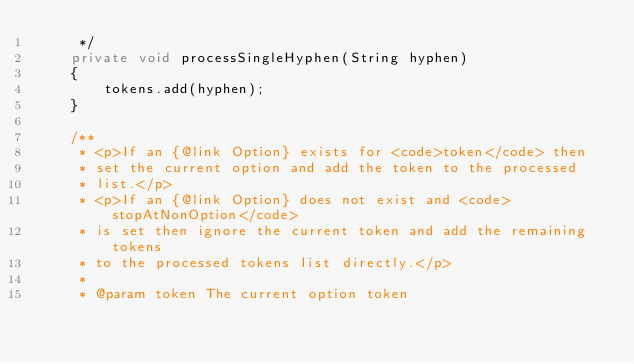<code> <loc_0><loc_0><loc_500><loc_500><_Java_>     */
    private void processSingleHyphen(String hyphen)
    {
        tokens.add(hyphen);
    }

    /**
     * <p>If an {@link Option} exists for <code>token</code> then
     * set the current option and add the token to the processed 
     * list.</p>
     * <p>If an {@link Option} does not exist and <code>stopAtNonOption</code>
     * is set then ignore the current token and add the remaining tokens
     * to the processed tokens list directly.</p>
     *
     * @param token The current option token</code> 